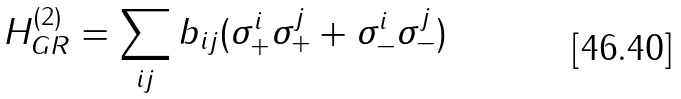<formula> <loc_0><loc_0><loc_500><loc_500>H _ { G R } ^ { ( 2 ) } = \sum _ { i j } b _ { i j } ( \sigma _ { + } ^ { i } \sigma _ { + } ^ { j } + \sigma _ { - } ^ { i } \sigma _ { - } ^ { j } )</formula> 